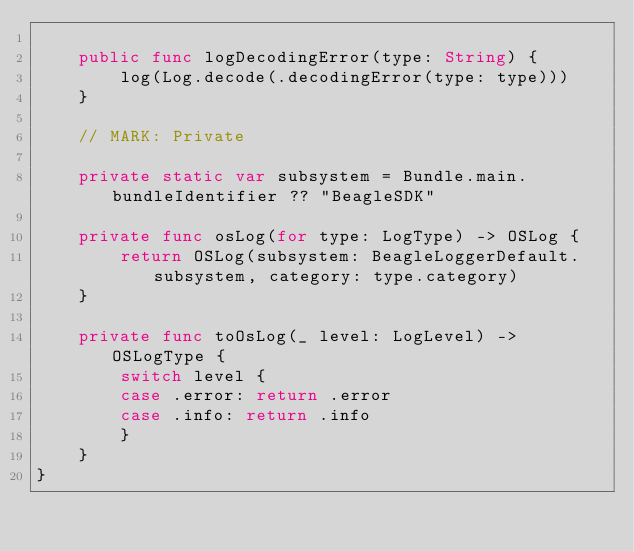Convert code to text. <code><loc_0><loc_0><loc_500><loc_500><_Swift_>    
    public func logDecodingError(type: String) {
        log(Log.decode(.decodingError(type: type)))
    }
    
    // MARK: Private

    private static var subsystem = Bundle.main.bundleIdentifier ?? "BeagleSDK"

    private func osLog(for type: LogType) -> OSLog {
        return OSLog(subsystem: BeagleLoggerDefault.subsystem, category: type.category)
    }
    
    private func toOsLog(_ level: LogLevel) -> OSLogType {
        switch level {
        case .error: return .error
        case .info: return .info
        }
    }
}
</code> 